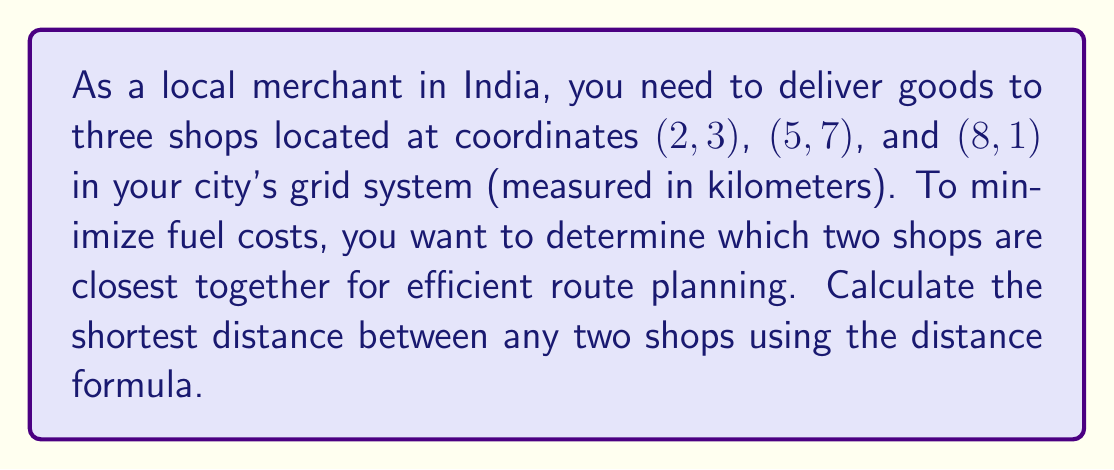Could you help me with this problem? To solve this problem, we'll use the distance formula between two points $(x_1, y_1)$ and $(x_2, y_2)$:

$$d = \sqrt{(x_2 - x_1)^2 + (y_2 - y_1)^2}$$

Let's calculate the distance between each pair of shops:

1. Distance between Shop 1 (2, 3) and Shop 2 (5, 7):
   $$d_{12} = \sqrt{(5 - 2)^2 + (7 - 3)^2} = \sqrt{3^2 + 4^2} = \sqrt{9 + 16} = \sqrt{25} = 5\text{ km}$$

2. Distance between Shop 1 (2, 3) and Shop 3 (8, 1):
   $$d_{13} = \sqrt{(8 - 2)^2 + (1 - 3)^2} = \sqrt{6^2 + (-2)^2} = \sqrt{36 + 4} = \sqrt{40} = 2\sqrt{10}\text{ km}$$

3. Distance between Shop 2 (5, 7) and Shop 3 (8, 1):
   $$d_{23} = \sqrt{(8 - 5)^2 + (1 - 7)^2} = \sqrt{3^2 + (-6)^2} = \sqrt{9 + 36} = \sqrt{45} = 3\sqrt{5}\text{ km}$$

Comparing the distances:
- $d_{12} = 5\text{ km}$
- $d_{13} = 2\sqrt{10} \approx 6.32\text{ km}$
- $d_{23} = 3\sqrt{5} \approx 6.71\text{ km}$

The shortest distance is between Shop 1 and Shop 2, which is 5 km.
Answer: 5 km 